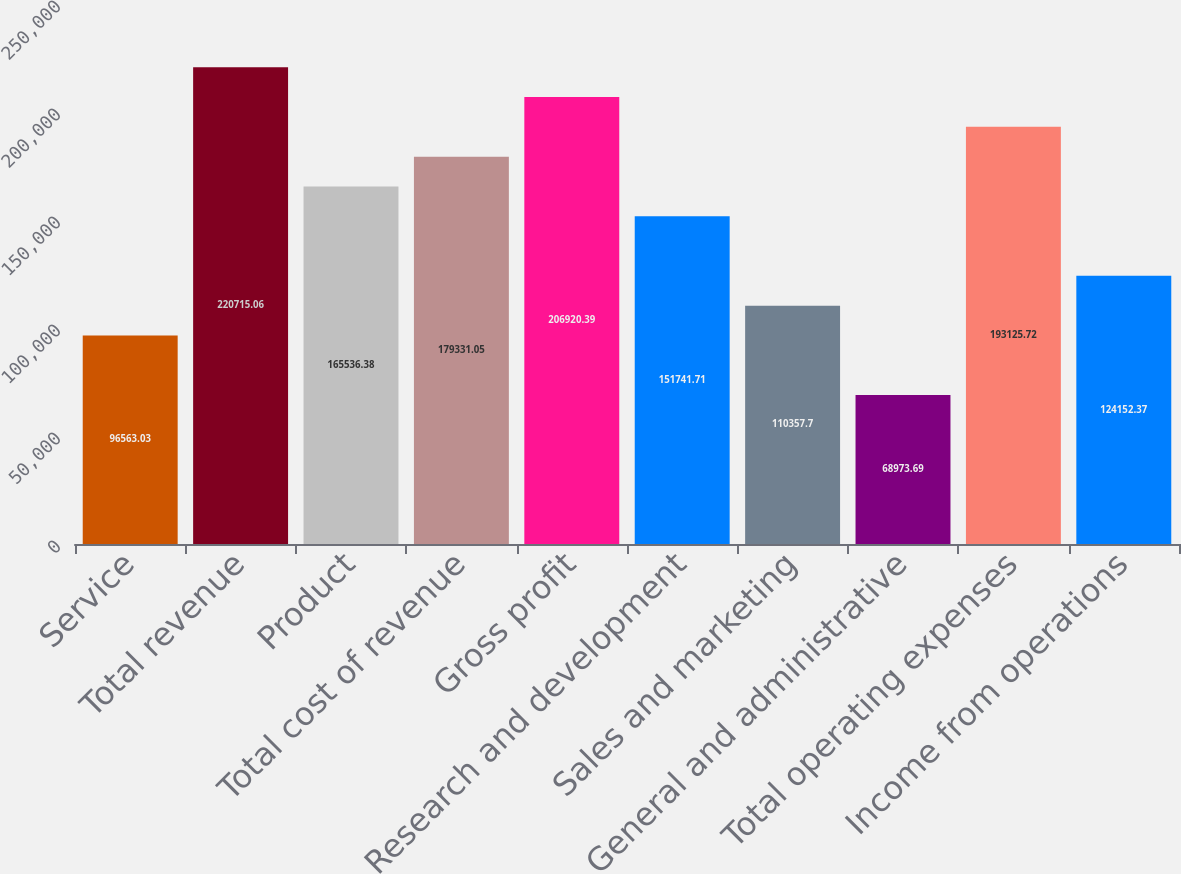Convert chart. <chart><loc_0><loc_0><loc_500><loc_500><bar_chart><fcel>Service<fcel>Total revenue<fcel>Product<fcel>Total cost of revenue<fcel>Gross profit<fcel>Research and development<fcel>Sales and marketing<fcel>General and administrative<fcel>Total operating expenses<fcel>Income from operations<nl><fcel>96563<fcel>220715<fcel>165536<fcel>179331<fcel>206920<fcel>151742<fcel>110358<fcel>68973.7<fcel>193126<fcel>124152<nl></chart> 